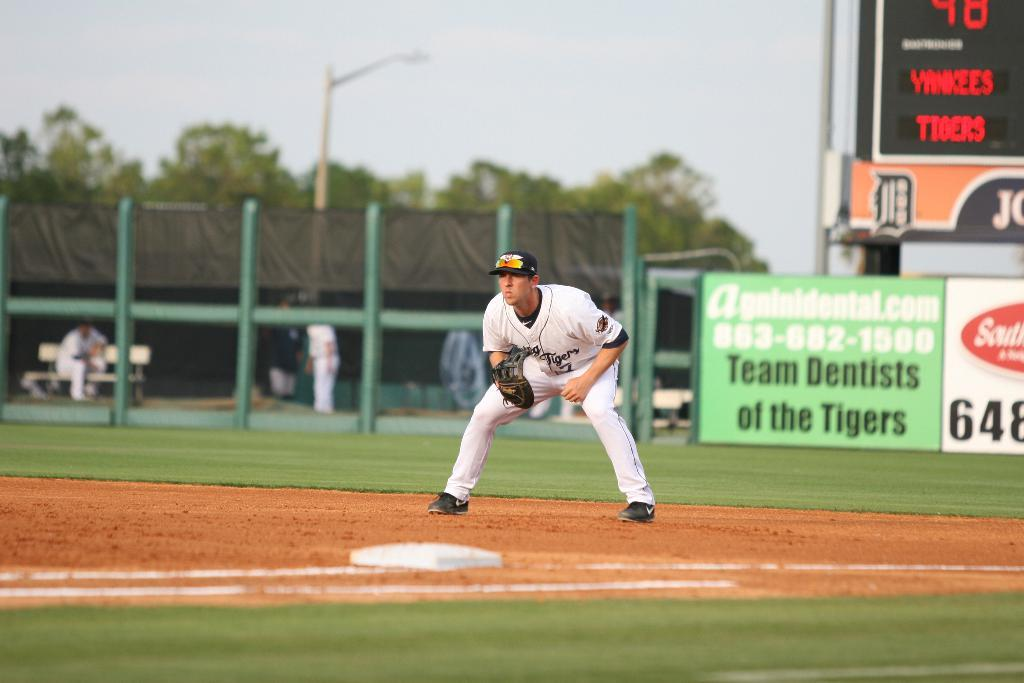<image>
Give a short and clear explanation of the subsequent image. A sign at the baseball field reads 'Team Dentists of the Tigers'. 